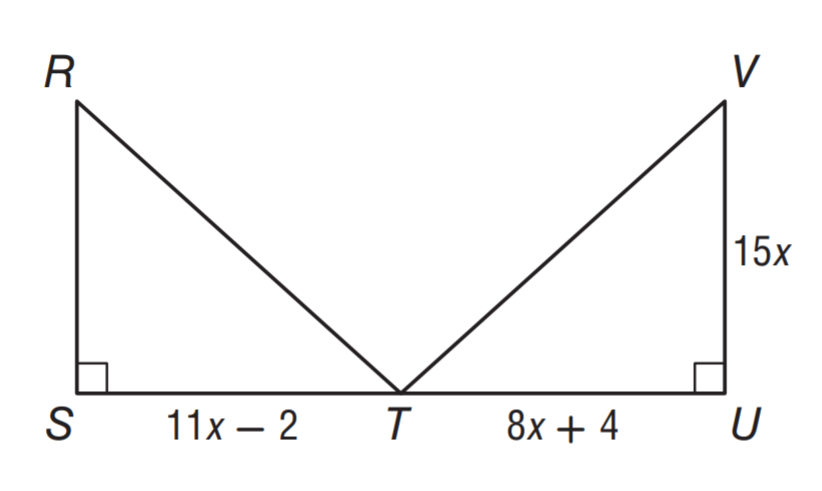Answer the mathemtical geometry problem and directly provide the correct option letter.
Question: \triangle R S T \cong \triangle V U T. Find x.
Choices: A: 1 B: 2 C: 3 D: 4 B 